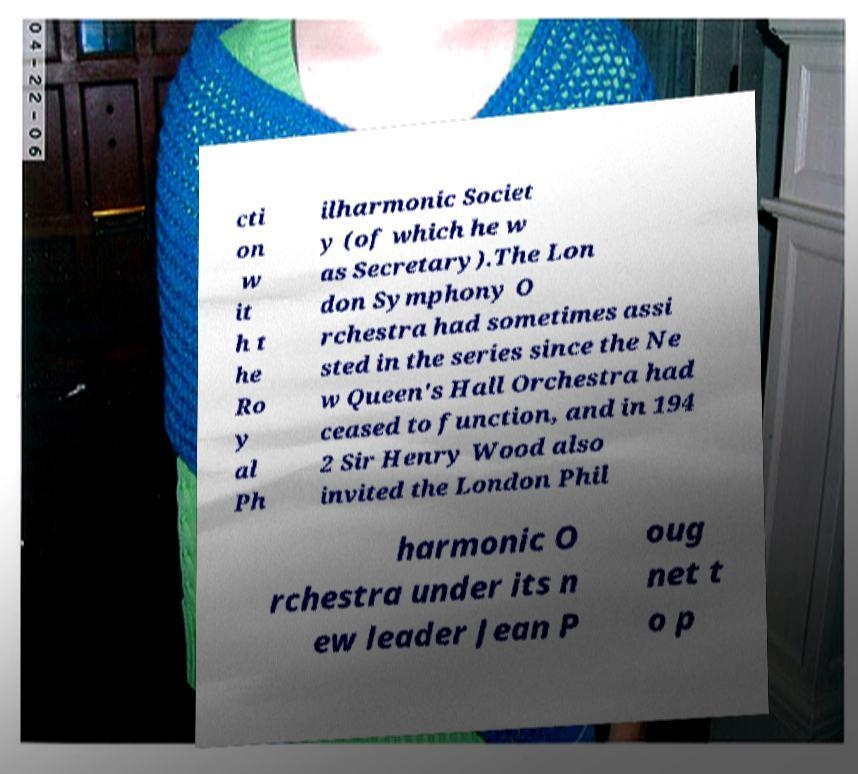Could you assist in decoding the text presented in this image and type it out clearly? cti on w it h t he Ro y al Ph ilharmonic Societ y (of which he w as Secretary).The Lon don Symphony O rchestra had sometimes assi sted in the series since the Ne w Queen's Hall Orchestra had ceased to function, and in 194 2 Sir Henry Wood also invited the London Phil harmonic O rchestra under its n ew leader Jean P oug net t o p 